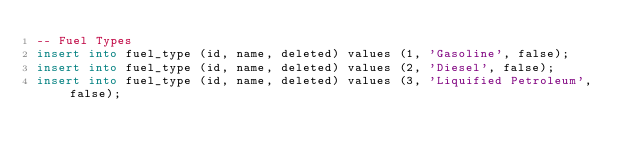<code> <loc_0><loc_0><loc_500><loc_500><_SQL_>-- Fuel Types
insert into fuel_type (id, name, deleted) values (1, 'Gasoline', false);
insert into fuel_type (id, name, deleted) values (2, 'Diesel', false);
insert into fuel_type (id, name, deleted) values (3, 'Liquified Petroleum', false);</code> 